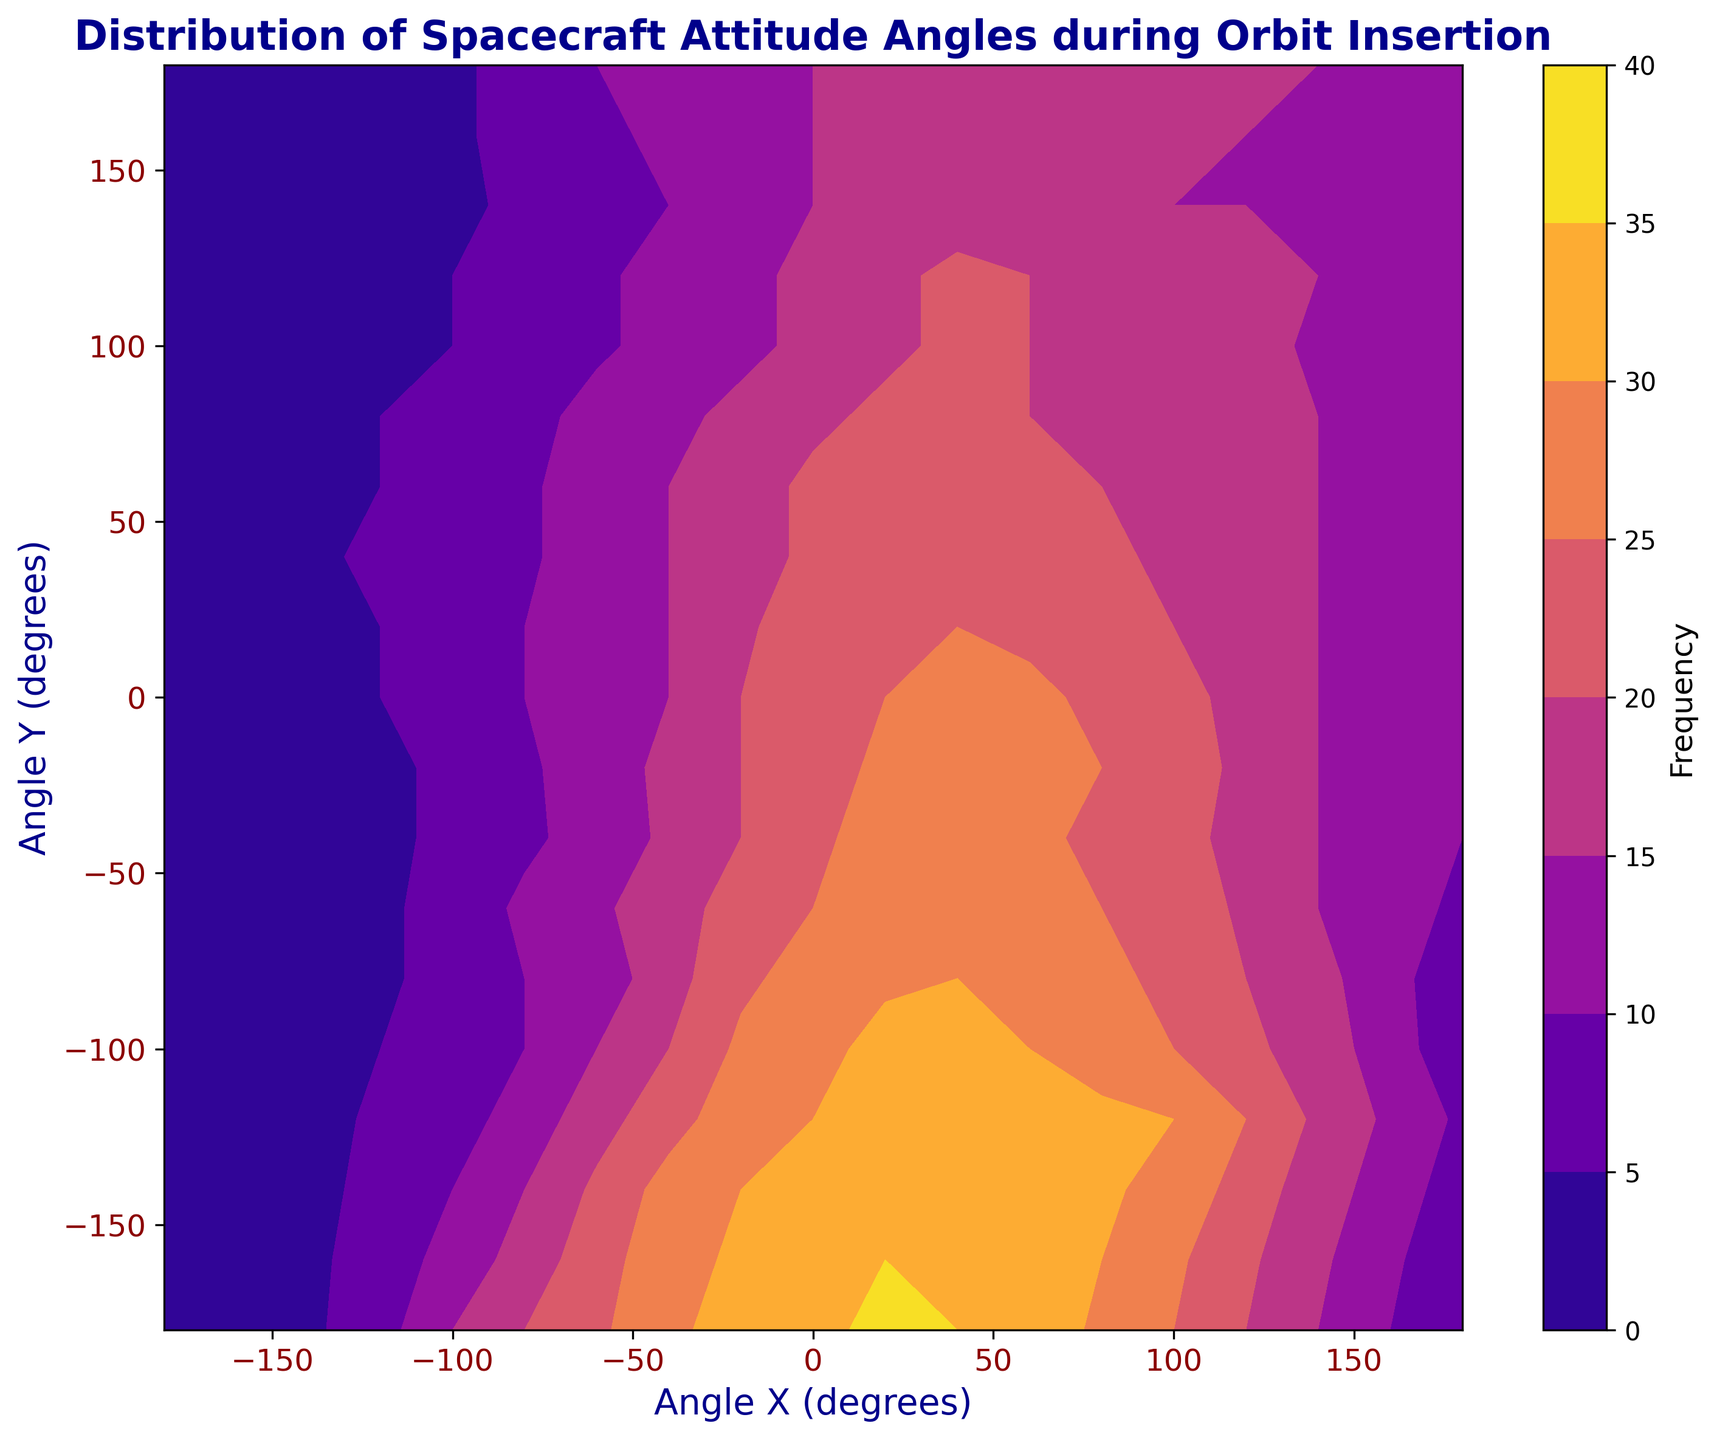What is the highest frequency observed, and at which angles does it occur? To answer this, look for the darkest region in the contour plot, which represents the highest frequency. Then, find the corresponding Angle X and Angle Y values.
Answer: 36 at (-180, 20) Which angle combination shows the lowest frequency of spacecraft attitude? Identify the lightest regions in the contour plot, representing the lowest frequency, and then note their corresponding X and Y angle values.
Answer: 0 at multiple points, e.g., (80, -180), (40, -180) How does the frequency distribution change along the angle X = -180 degrees from angle Y = -180 to angle Y = 180? Observe the contour line along Angle X = -180 degrees and note the change in frequency values as Angle Y moves from -180 to 180.
Answer: Starts at 2, peaks at 36 near Y= 20, and drops to 5 at Y=180 Compare the frequency at Angle X = 0, Angle Y = 0 to the frequency at Angle X = 180, Angle Y = 0. Which is higher? Locate the contour points for (0, 0) and (180, 0), then compare their frequency values.
Answer: Angle X=0, Angle Y=0 has a frequency of 24; Angle X=180, Angle Y=0 has a frequency of 15. So, (0, 0) is higher Which angle Y has the lowest average frequency combining all angle X values? Calculate and compare the average frequencies across all angle X values for each angle Y to find the lowest average frequency.
Answer: Angle Y = -180 with an average frequency of 0.9 Are there any symmetries observed in the frequency distribution of the contour plot? Examine if there are any mirror patterns or repeating frequency trends across the contour plot for both positive and negative values of Angle X and Y.
Answer: Yes, approximate symmetry about center 